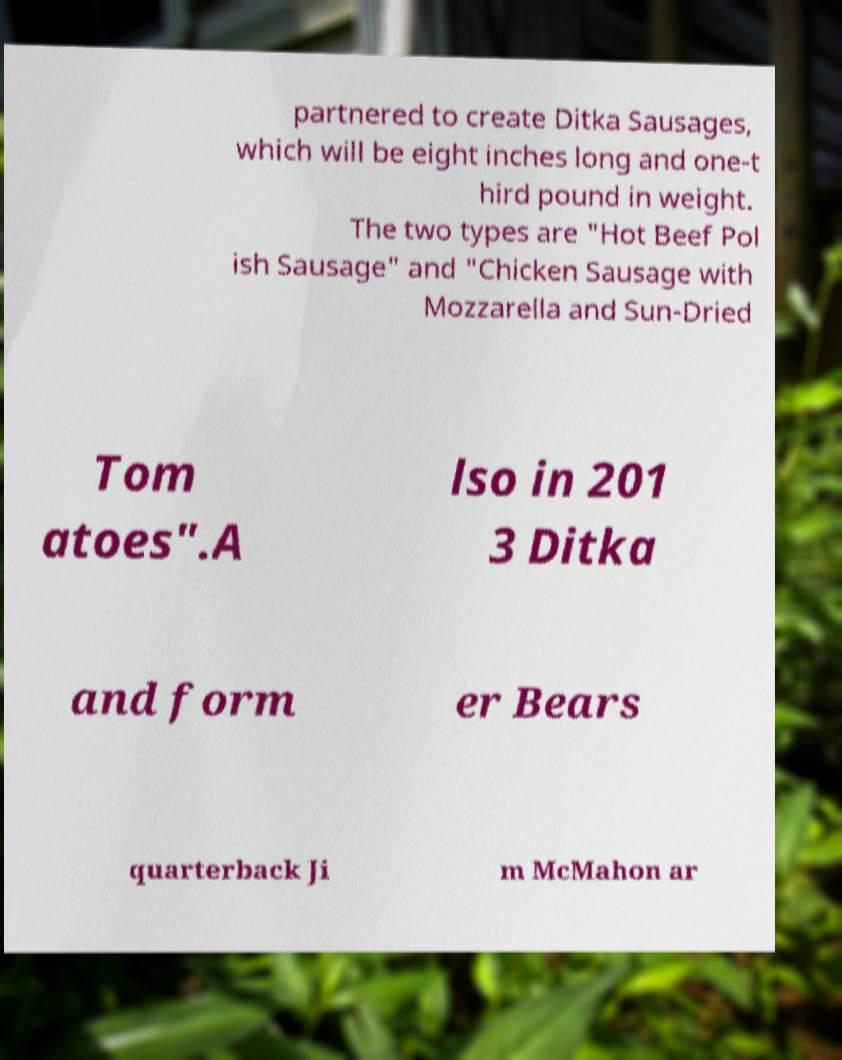Can you accurately transcribe the text from the provided image for me? partnered to create Ditka Sausages, which will be eight inches long and one-t hird pound in weight. The two types are "Hot Beef Pol ish Sausage" and "Chicken Sausage with Mozzarella and Sun-Dried Tom atoes".A lso in 201 3 Ditka and form er Bears quarterback Ji m McMahon ar 